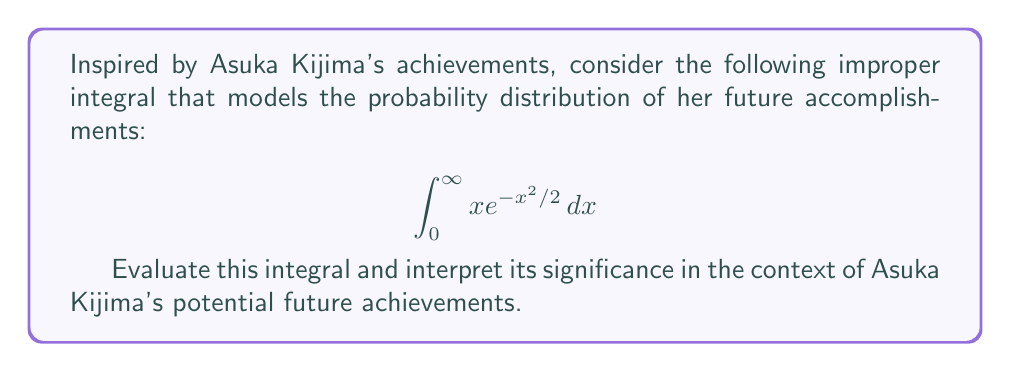What is the answer to this math problem? Let's approach this step-by-step:

1) First, we recognize this as an improper integral of the form $\int_0^\infty f(x)\,dx$.

2) To evaluate this, we can use the substitution method. Let $u = x^2/2$, then $du = x\,dx$.

3) Rewriting the integral in terms of $u$:

   $$\int_0^\infty xe^{-x^2/2}\,dx = \int_0^\infty e^{-u}\,du$$

4) Now we have a standard integral form. The integral of $e^{-u}$ is $-e^{-u}$.

5) Evaluating from 0 to $\infty$:

   $$\left[-e^{-u}\right]_0^\infty = \lim_{t\to\infty} (-e^{-t}) - (-e^0) = 0 - (-1) = 1$$

6) Therefore, the integral evaluates to 1.

Interpretation: In probability theory, this integral represents the expected value of a standard half-normal distribution. In the context of Asuka Kijima's achievements, we can interpret this as follows:

- The x-axis represents the magnitude of future achievements.
- The exponential term $e^{-x^2/2}$ suggests that while smaller achievements are more likely, there's still a possibility of extraordinary accomplishments.
- The fact that the integral equals 1 confirms that this is a valid probability distribution, encompassing all possible future outcomes.
- The expected value being 1 indicates a balanced outlook: fans can anticipate significant future achievements from Asuka Kijima, but these are tempered by realistic probabilities.
Answer: The value of the integral is 1. 